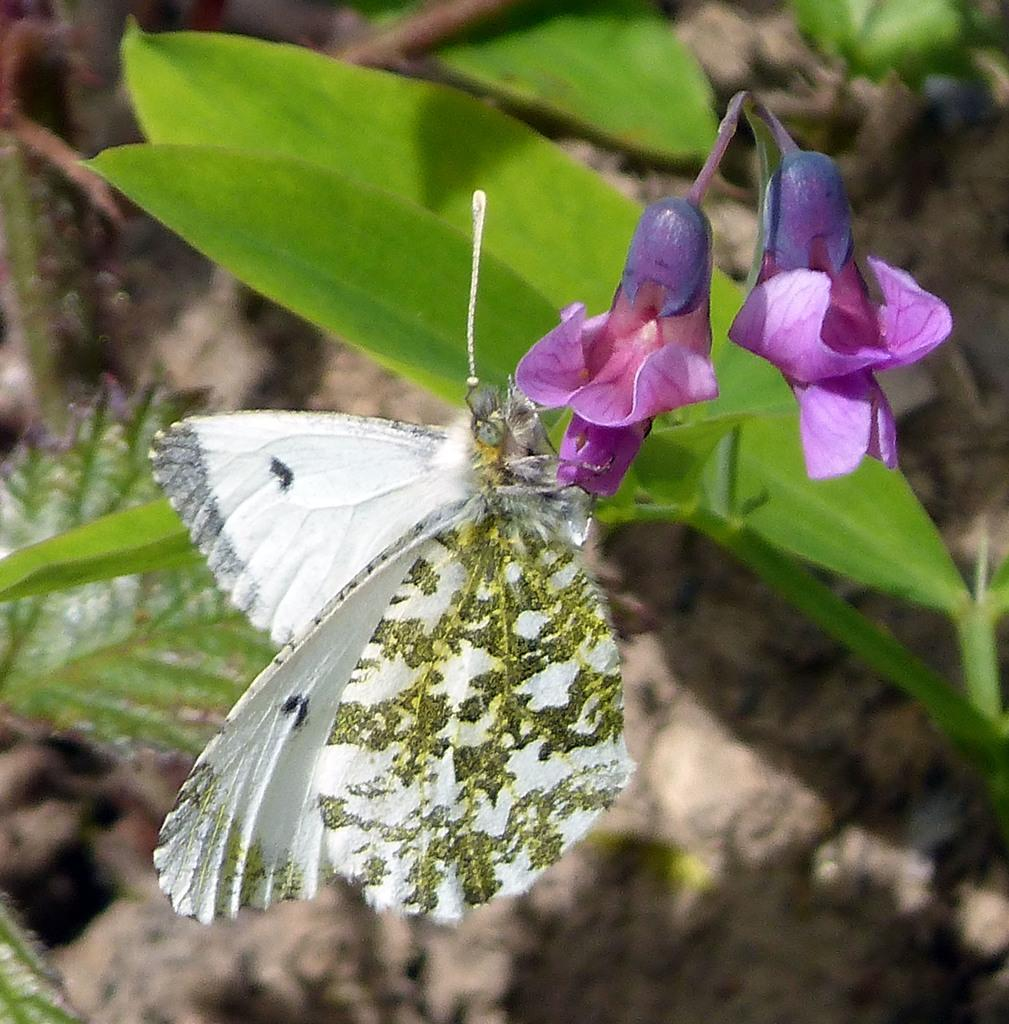What type of flowers are on the plant in the image? There are pink flowers on the plant in the image. What insect is present on the flower? There is a white butterfly on the flower. Can you describe the appearance of the butterfly? The butterfly has some designs. How would you describe the background of the image? The background of the image is blurred. Where is the nest of the butterfly located in the image? There is no nest present in the image; it only shows a white butterfly on a pink flower. 